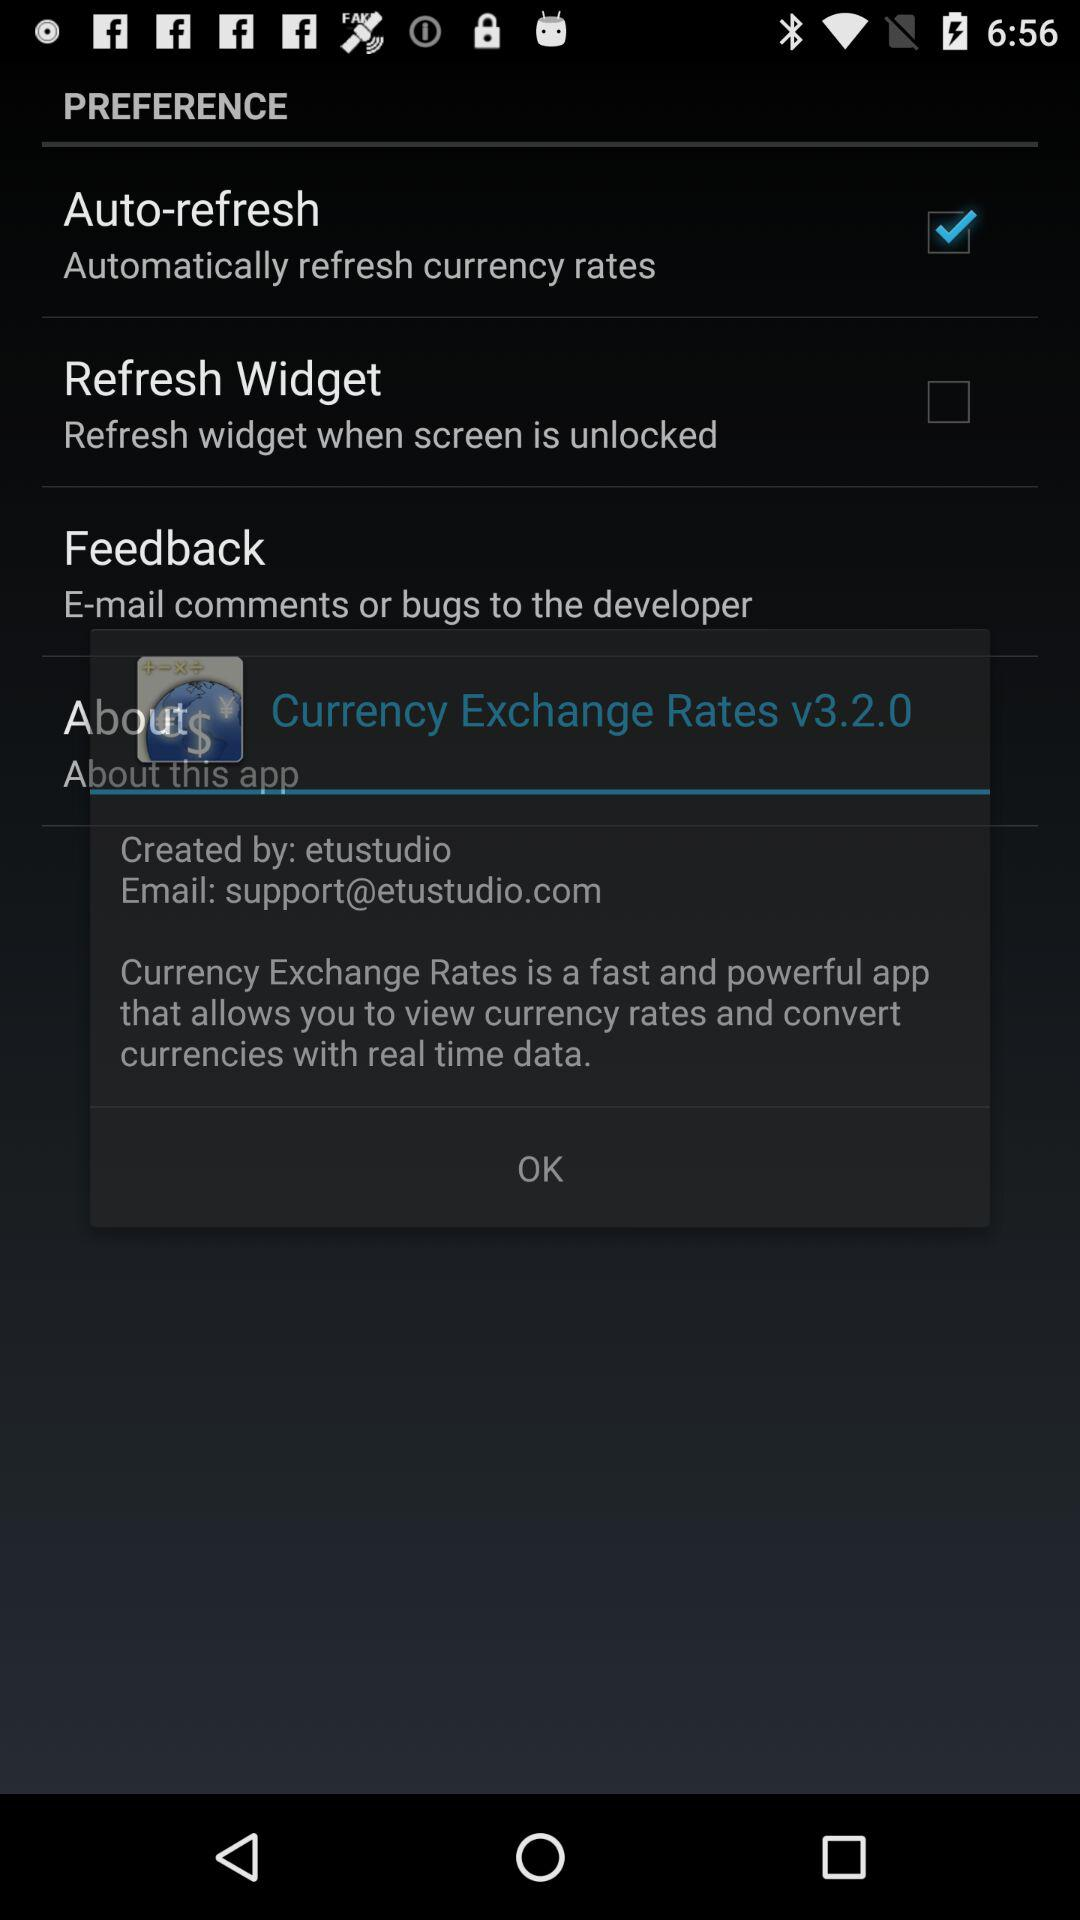How much USD is equivalent to 0.9349 EUR? 0.9349 EUR is equivalent to 1 USD. 